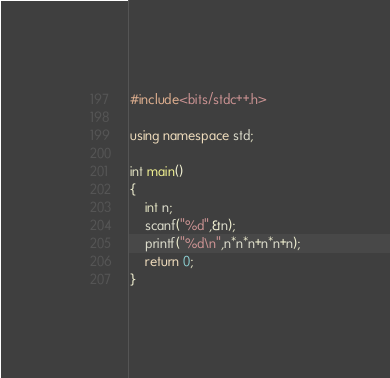<code> <loc_0><loc_0><loc_500><loc_500><_C++_>#include<bits/stdc++.h>

using namespace std;

int main()
{
    int n;
    scanf("%d",&n);
    printf("%d\n",n*n*n+n*n+n);
    return 0;
}
</code> 